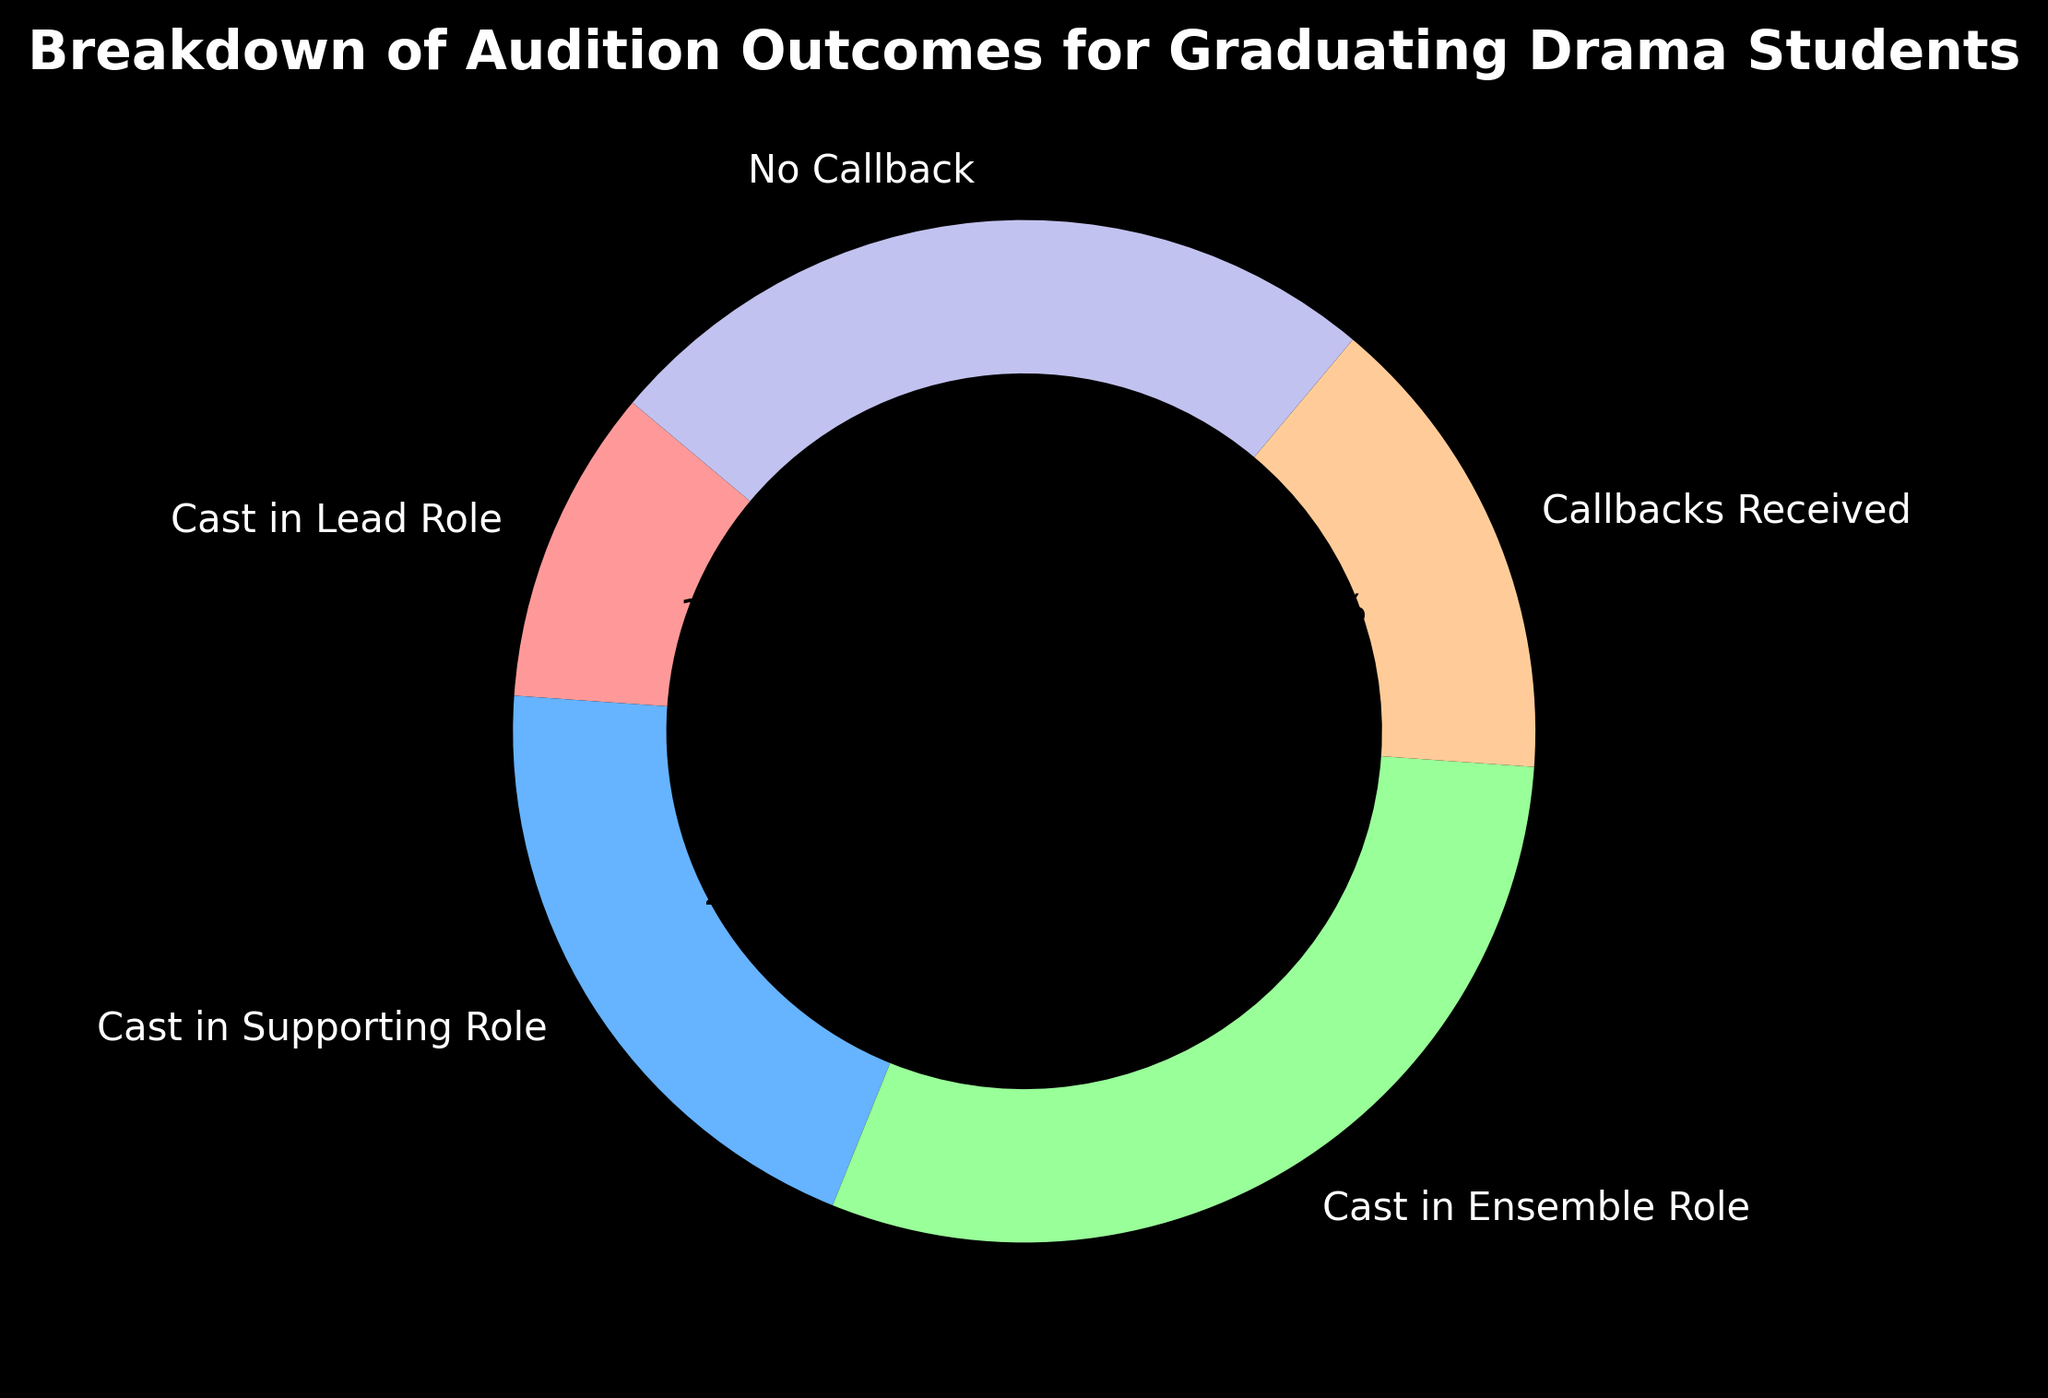What's the highest percentage category in the pie chart? To find the highest percentage category, we need to identify the segment with the largest percentage value. From the given data, "Cast in Ensemble Role" has the highest percentage at 30%.
Answer: Cast in Ensemble Role Which category has a larger percentage: "Callbacks Received" or "No Callback"? "Callbacks Received" has 15% and "No Callback" has 25%. Comparing these values, "No Callback" has a larger percentage.
Answer: No Callback What is the total percentage of roles (lead, supporting, ensemble)? To find the total percentage of roles, we add the percentages of "Cast in Lead Role" (10%), "Cast in Supporting Role" (20%), and "Cast in Ensemble Role" (30%). The sum is 10 + 20 + 30 = 60%.
Answer: 60% Which category has the smallest percentage, and what is it? To find the smallest percentage, we compare all the provided percentages. The smallest percentage value is 10%, which corresponds to the "Cast in Lead Role" category.
Answer: Cast in Lead Role What is the difference in percentage between "Cast in Supporting Role" and "Cast in Ensemble Role"? "Cast in Supporting Role" has 20%, and "Cast in Ensemble Role" has 30%. The difference is calculated by 30% - 20% = 10%.
Answer: 10% How many categories have a percentage of 20% or higher? We count the categories that have a percentage of 20% or higher. "Cast in Supporting Role" (20%), "Cast in Ensemble Role" (30%), and "No Callback" (25%) meet this criterion, totaling three categories.
Answer: 3 What percentage do categories related to callbacks ("Callbacks Received" and "No Callback") make up together? Add "Callbacks Received" (15%) and "No Callback" (25%) to find their combined percentage: 15% + 25% = 40%.
Answer: 40% If the total number of auditions is 1000, how many students were cast in a lead or supporting role? Calculate based on percentages: 
- Cast in Lead Role: 10% of 1000 = 0.1 * 1000 = 100
- Cast in Supporting Role: 20% of 1000 = 0.2 * 1000 = 200
Combine the two: 100 + 200 = 300 students.
Answer: 300 What color represents the "Cast in Ensemble Role" category in the pie chart? From the description, "Cast in Ensemble Role" is represented by the color green.
Answer: Green 